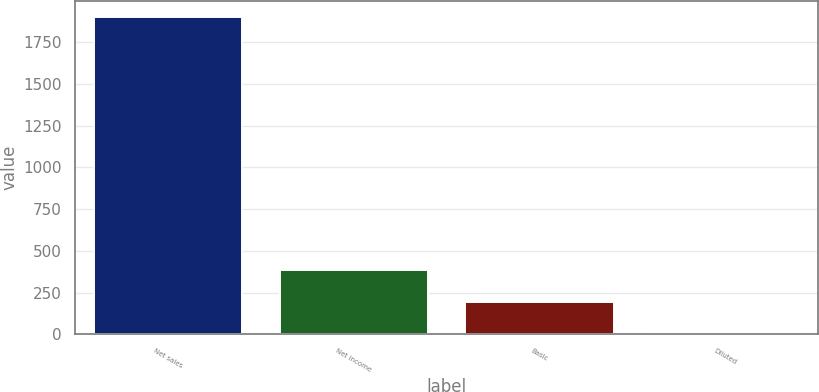Convert chart. <chart><loc_0><loc_0><loc_500><loc_500><bar_chart><fcel>Net sales<fcel>Net income<fcel>Basic<fcel>Diluted<nl><fcel>1899.6<fcel>381.88<fcel>192.17<fcel>2.46<nl></chart> 